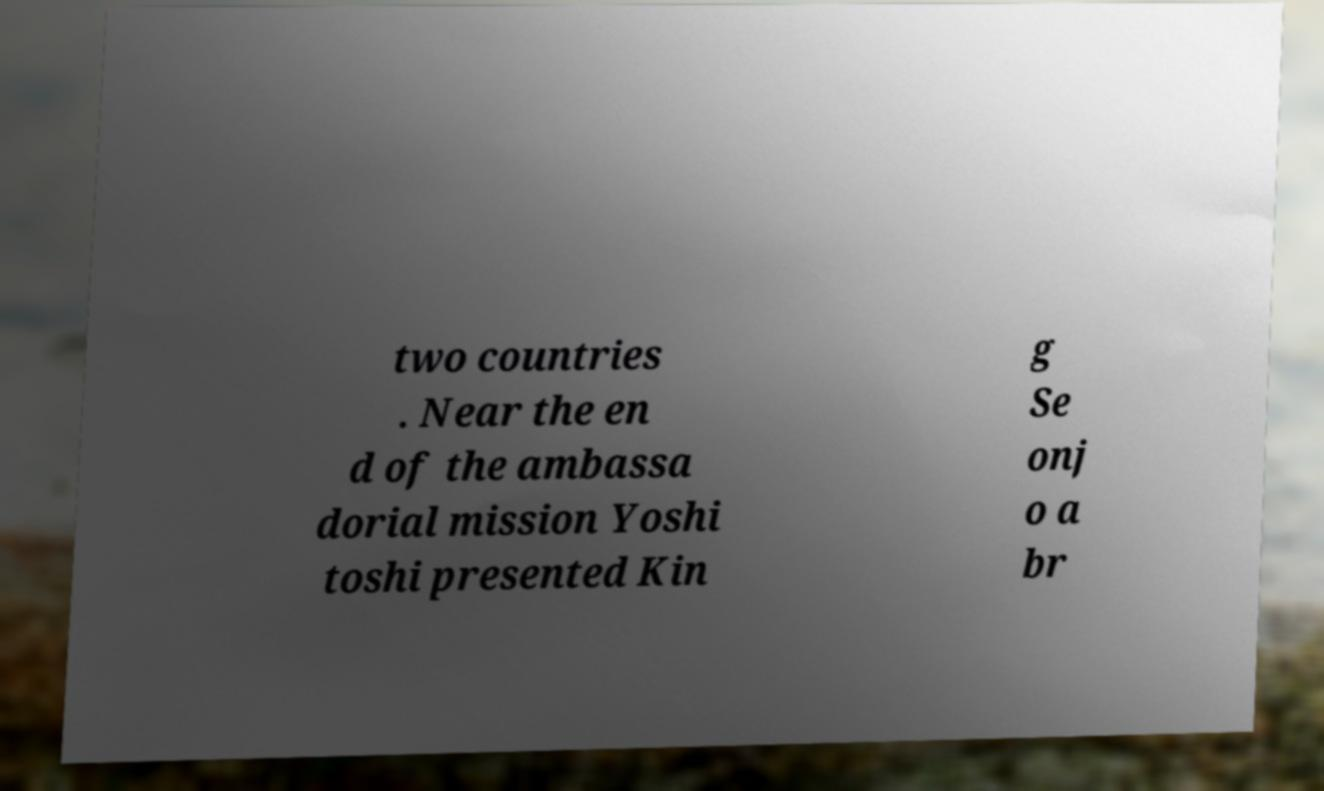Could you extract and type out the text from this image? two countries . Near the en d of the ambassa dorial mission Yoshi toshi presented Kin g Se onj o a br 